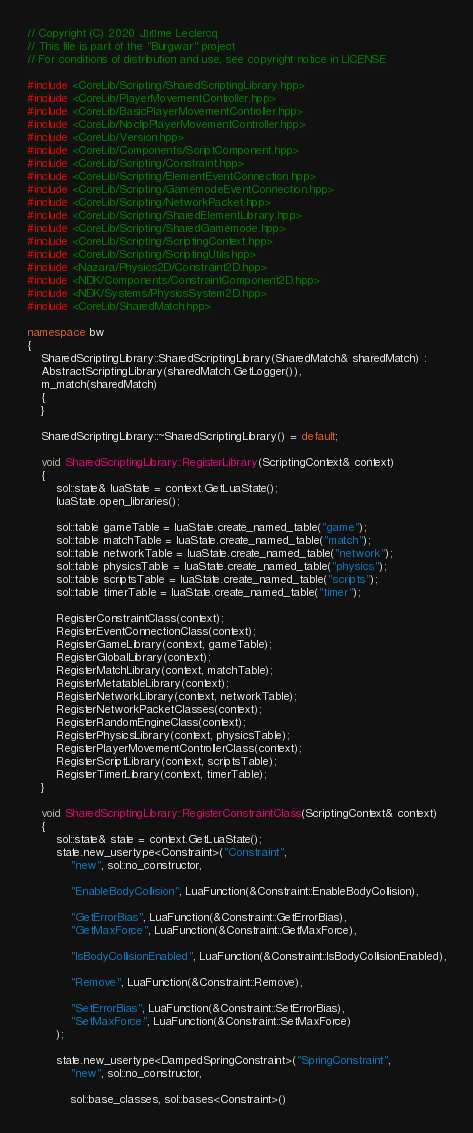<code> <loc_0><loc_0><loc_500><loc_500><_C++_>// Copyright (C) 2020 Jérôme Leclercq
// This file is part of the "Burgwar" project
// For conditions of distribution and use, see copyright notice in LICENSE

#include <CoreLib/Scripting/SharedScriptingLibrary.hpp>
#include <CoreLib/PlayerMovementController.hpp>
#include <CoreLib/BasicPlayerMovementController.hpp>
#include <CoreLib/NoclipPlayerMovementController.hpp>
#include <CoreLib/Version.hpp>
#include <CoreLib/Components/ScriptComponent.hpp>
#include <CoreLib/Scripting/Constraint.hpp>
#include <CoreLib/Scripting/ElementEventConnection.hpp>
#include <CoreLib/Scripting/GamemodeEventConnection.hpp>
#include <CoreLib/Scripting/NetworkPacket.hpp>
#include <CoreLib/Scripting/SharedElementLibrary.hpp>
#include <CoreLib/Scripting/SharedGamemode.hpp>
#include <CoreLib/Scripting/ScriptingContext.hpp>
#include <CoreLib/Scripting/ScriptingUtils.hpp>
#include <Nazara/Physics2D/Constraint2D.hpp>
#include <NDK/Components/ConstraintComponent2D.hpp>
#include <NDK/Systems/PhysicsSystem2D.hpp>
#include <CoreLib/SharedMatch.hpp>

namespace bw
{
	SharedScriptingLibrary::SharedScriptingLibrary(SharedMatch& sharedMatch) :
	AbstractScriptingLibrary(sharedMatch.GetLogger()),
	m_match(sharedMatch)
	{
	}

	SharedScriptingLibrary::~SharedScriptingLibrary() = default;

	void SharedScriptingLibrary::RegisterLibrary(ScriptingContext& context)
	{
		sol::state& luaState = context.GetLuaState();
		luaState.open_libraries();

		sol::table gameTable = luaState.create_named_table("game");
		sol::table matchTable = luaState.create_named_table("match");
		sol::table networkTable = luaState.create_named_table("network");
		sol::table physicsTable = luaState.create_named_table("physics");
		sol::table scriptsTable = luaState.create_named_table("scripts");
		sol::table timerTable = luaState.create_named_table("timer");

		RegisterConstraintClass(context);
		RegisterEventConnectionClass(context);
		RegisterGameLibrary(context, gameTable);
		RegisterGlobalLibrary(context);
		RegisterMatchLibrary(context, matchTable);
		RegisterMetatableLibrary(context);
		RegisterNetworkLibrary(context, networkTable);
		RegisterNetworkPacketClasses(context);
		RegisterRandomEngineClass(context);
		RegisterPhysicsLibrary(context, physicsTable);
		RegisterPlayerMovementControllerClass(context);
		RegisterScriptLibrary(context, scriptsTable);
		RegisterTimerLibrary(context, timerTable);
	}

	void SharedScriptingLibrary::RegisterConstraintClass(ScriptingContext& context)
	{
		sol::state& state = context.GetLuaState();
		state.new_usertype<Constraint>("Constraint",
			"new", sol::no_constructor,

			"EnableBodyCollision", LuaFunction(&Constraint::EnableBodyCollision),

			"GetErrorBias", LuaFunction(&Constraint::GetErrorBias),
			"GetMaxForce", LuaFunction(&Constraint::GetMaxForce),

			"IsBodyCollisionEnabled", LuaFunction(&Constraint::IsBodyCollisionEnabled),

			"Remove", LuaFunction(&Constraint::Remove),

			"SetErrorBias", LuaFunction(&Constraint::SetErrorBias),
			"SetMaxForce", LuaFunction(&Constraint::SetMaxForce)
		);

		state.new_usertype<DampedSpringConstraint>("SpringConstraint",
			"new", sol::no_constructor,

			sol::base_classes, sol::bases<Constraint>()</code> 